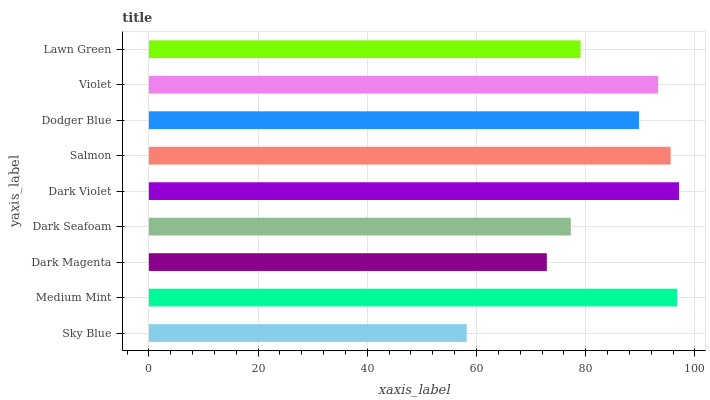Is Sky Blue the minimum?
Answer yes or no. Yes. Is Dark Violet the maximum?
Answer yes or no. Yes. Is Medium Mint the minimum?
Answer yes or no. No. Is Medium Mint the maximum?
Answer yes or no. No. Is Medium Mint greater than Sky Blue?
Answer yes or no. Yes. Is Sky Blue less than Medium Mint?
Answer yes or no. Yes. Is Sky Blue greater than Medium Mint?
Answer yes or no. No. Is Medium Mint less than Sky Blue?
Answer yes or no. No. Is Dodger Blue the high median?
Answer yes or no. Yes. Is Dodger Blue the low median?
Answer yes or no. Yes. Is Dark Violet the high median?
Answer yes or no. No. Is Sky Blue the low median?
Answer yes or no. No. 